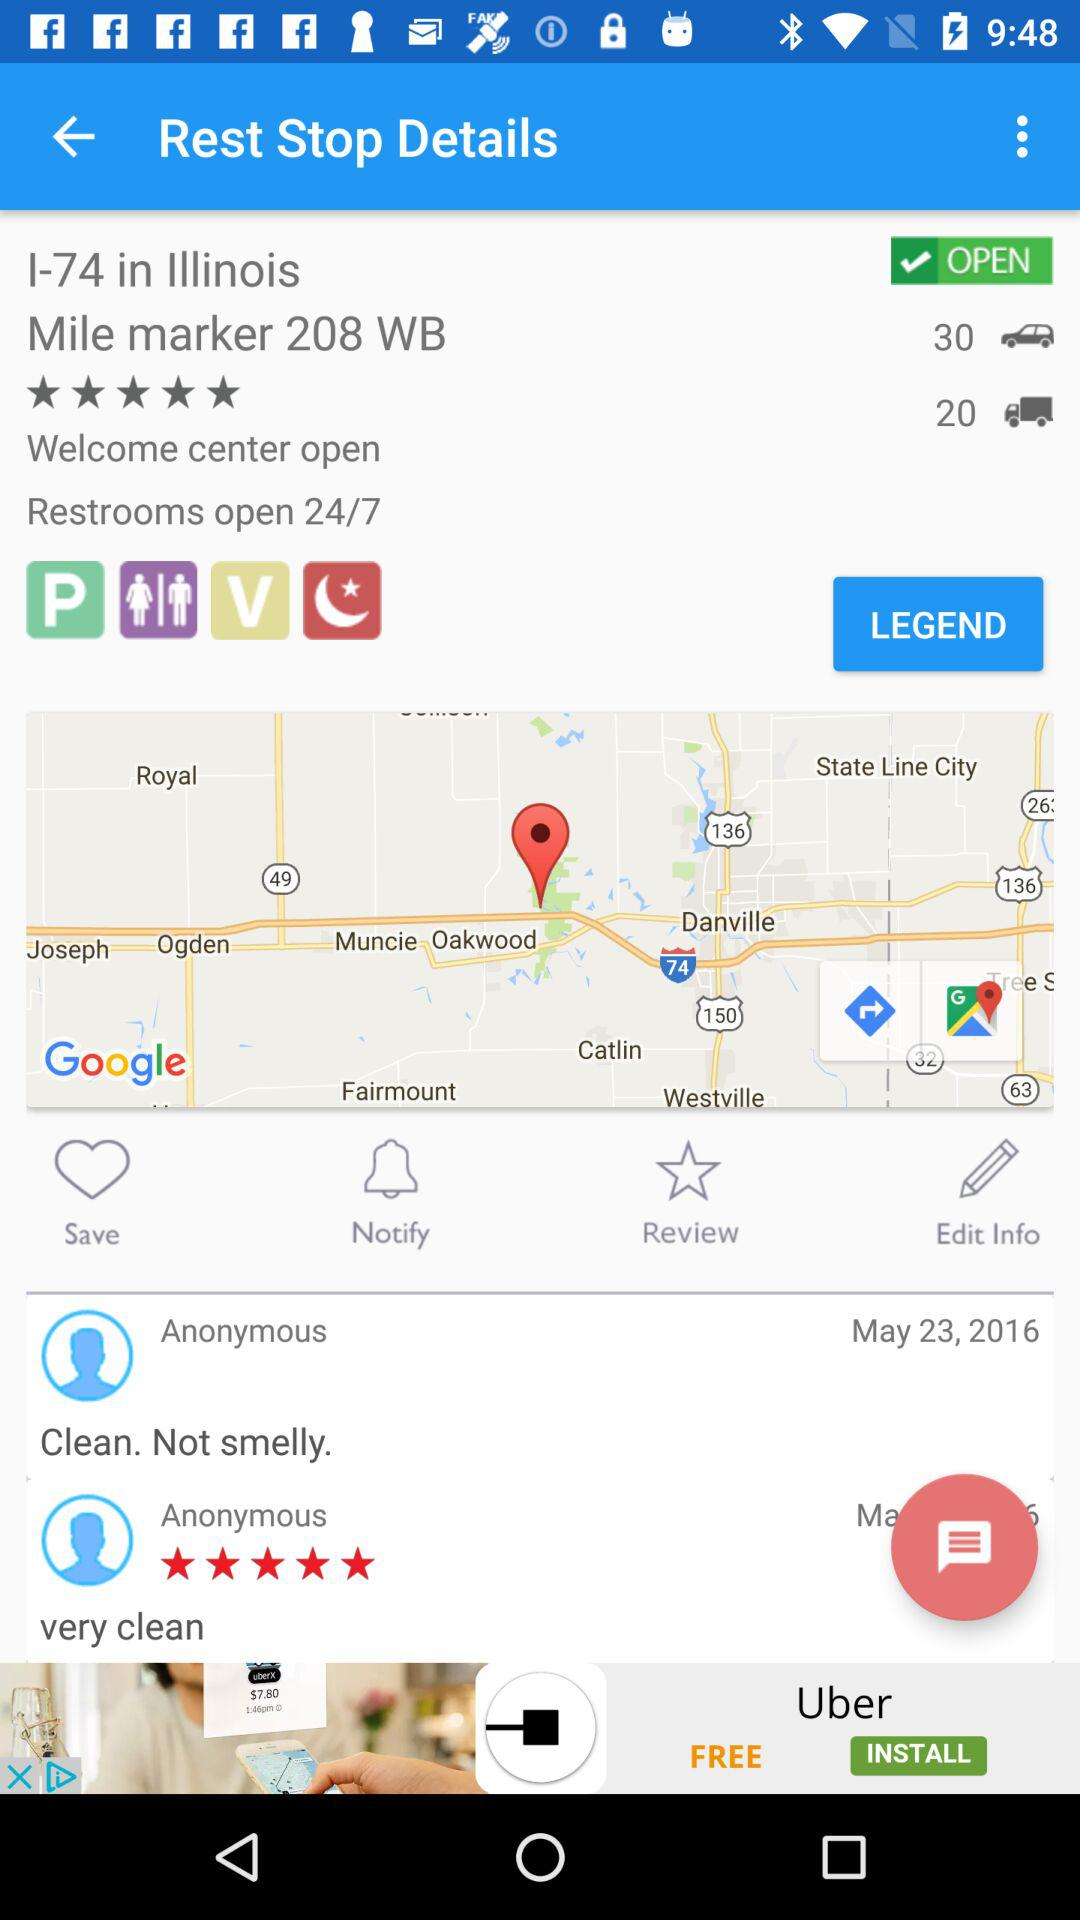How many reviews does the rest stop have?
Answer the question using a single word or phrase. 2 